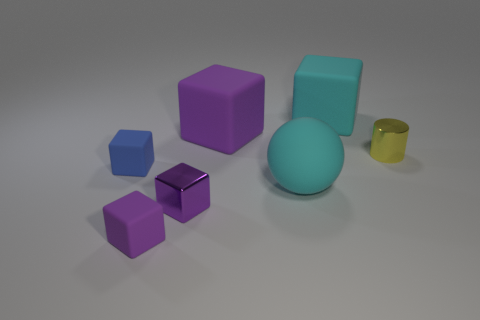How many purple blocks must be subtracted to get 1 purple blocks? 2 Subtract all cyan balls. How many purple cubes are left? 3 Subtract all blue blocks. How many blocks are left? 4 Subtract all large cyan blocks. How many blocks are left? 4 Add 3 small yellow shiny cylinders. How many objects exist? 10 Subtract all brown balls. Subtract all green blocks. How many balls are left? 1 Subtract all blocks. How many objects are left? 2 Add 2 big cyan blocks. How many big cyan blocks exist? 3 Subtract 1 blue blocks. How many objects are left? 6 Subtract all big rubber objects. Subtract all large rubber balls. How many objects are left? 3 